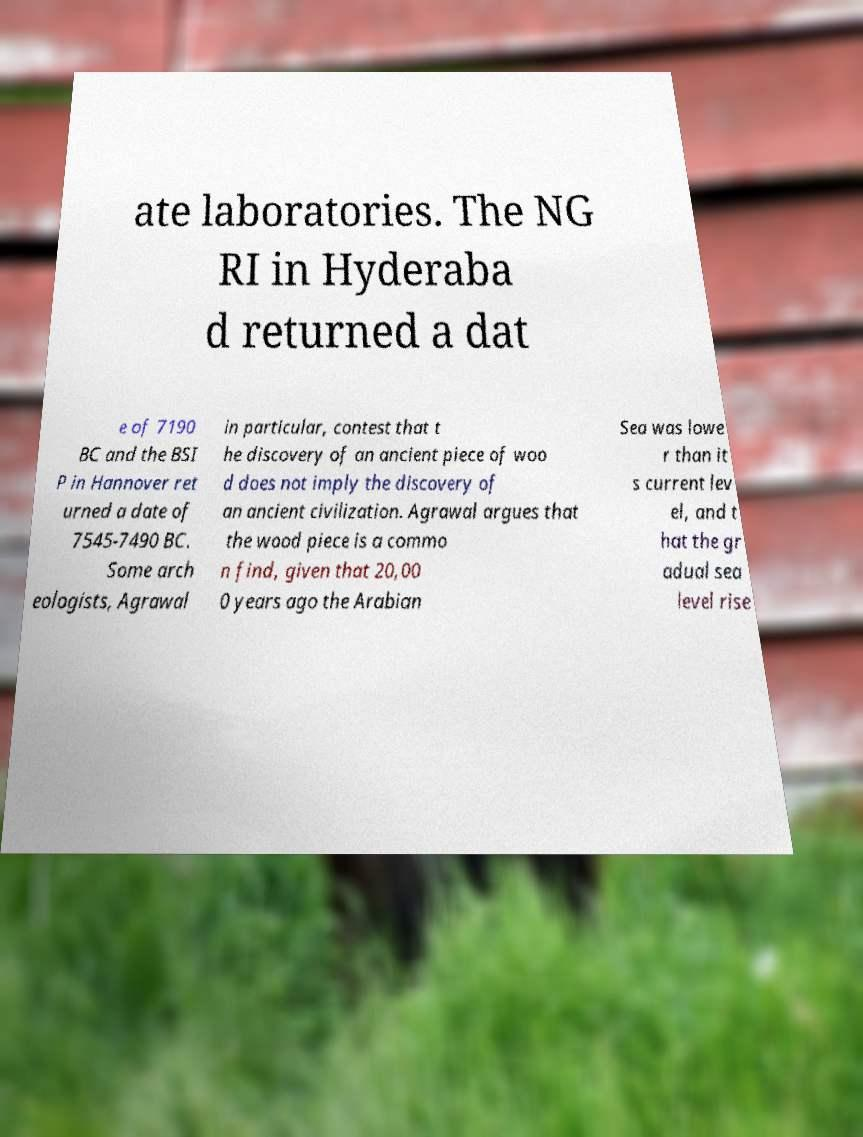There's text embedded in this image that I need extracted. Can you transcribe it verbatim? ate laboratories. The NG RI in Hyderaba d returned a dat e of 7190 BC and the BSI P in Hannover ret urned a date of 7545-7490 BC. Some arch eologists, Agrawal in particular, contest that t he discovery of an ancient piece of woo d does not imply the discovery of an ancient civilization. Agrawal argues that the wood piece is a commo n find, given that 20,00 0 years ago the Arabian Sea was lowe r than it s current lev el, and t hat the gr adual sea level rise 